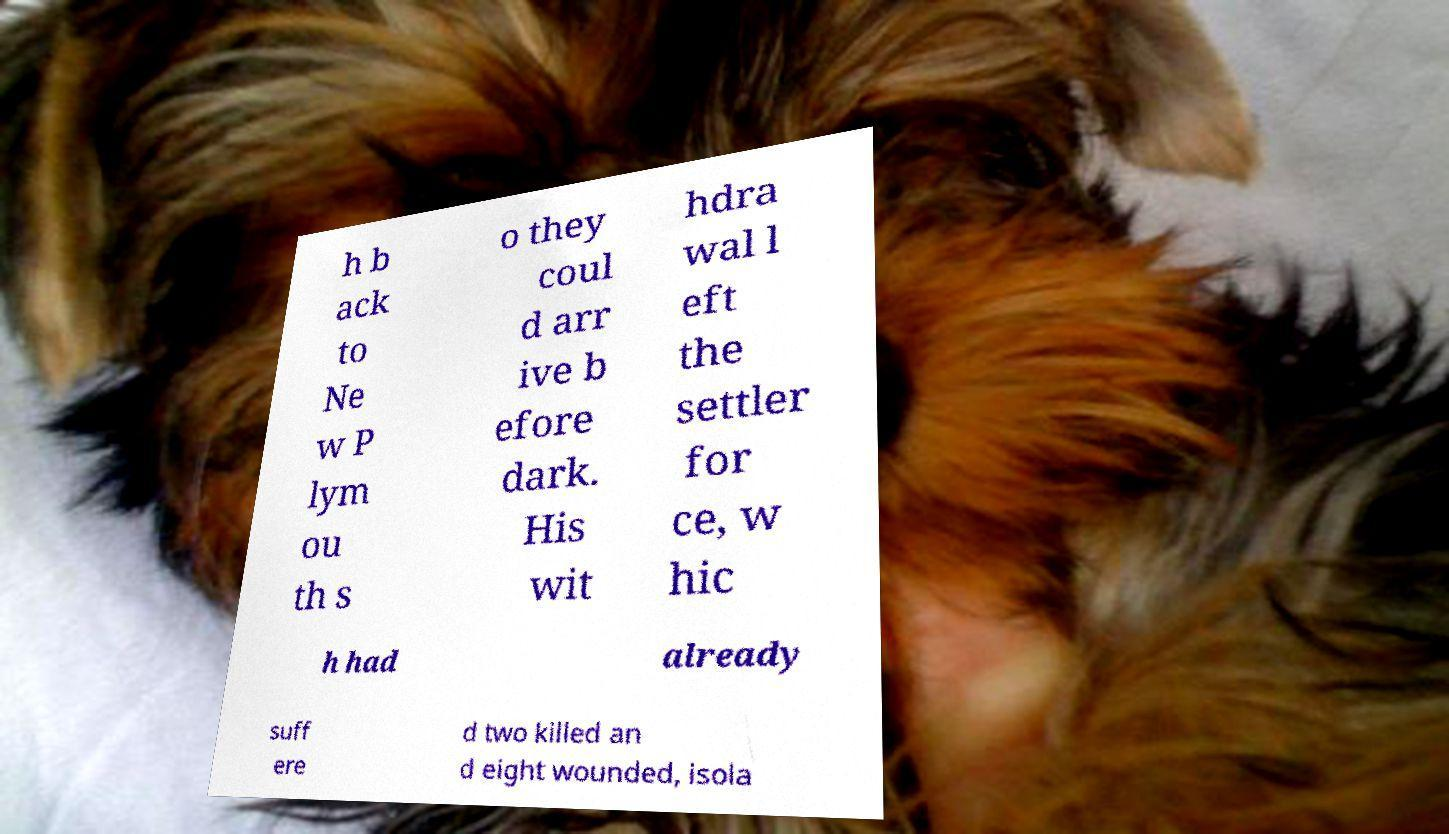There's text embedded in this image that I need extracted. Can you transcribe it verbatim? h b ack to Ne w P lym ou th s o they coul d arr ive b efore dark. His wit hdra wal l eft the settler for ce, w hic h had already suff ere d two killed an d eight wounded, isola 